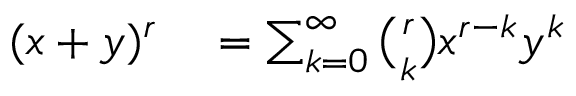<formula> <loc_0><loc_0><loc_500><loc_500>\begin{array} { r l } { ( x + y ) ^ { r } } & = \sum _ { k = 0 } ^ { \infty } { \binom { r } { k } } x ^ { r - k } y ^ { k } } \end{array}</formula> 